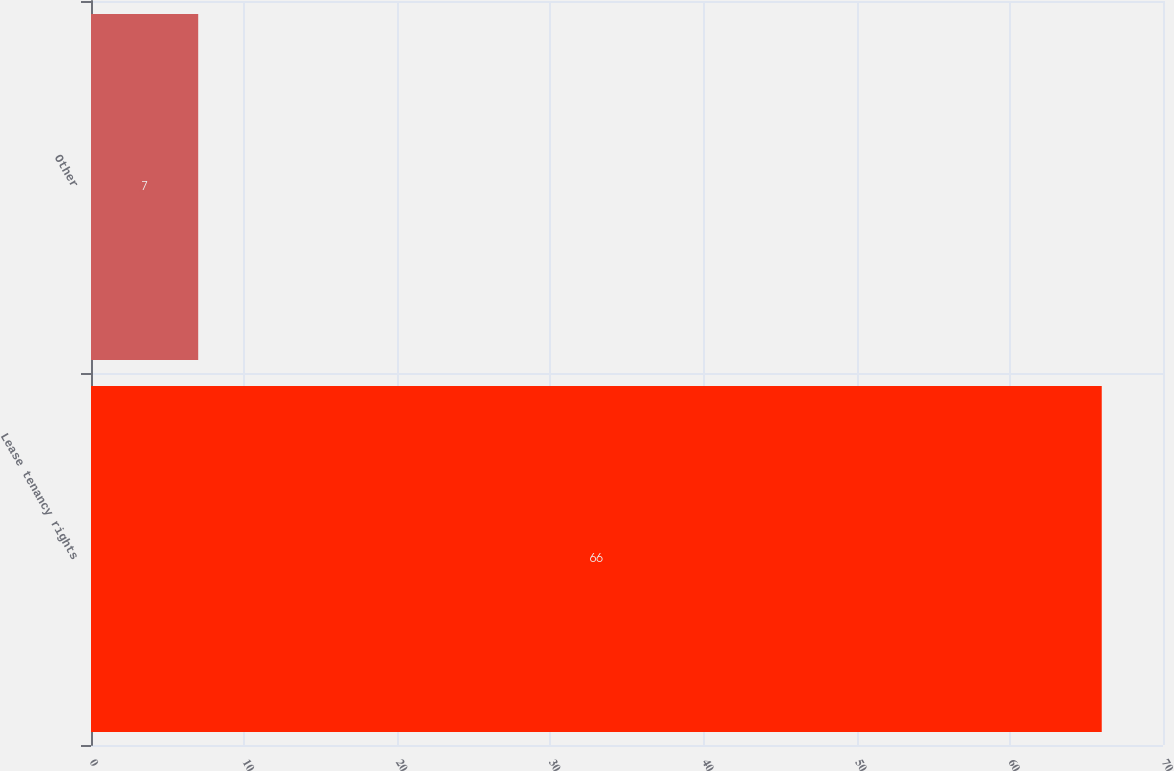Convert chart to OTSL. <chart><loc_0><loc_0><loc_500><loc_500><bar_chart><fcel>Lease tenancy rights<fcel>Other<nl><fcel>66<fcel>7<nl></chart> 